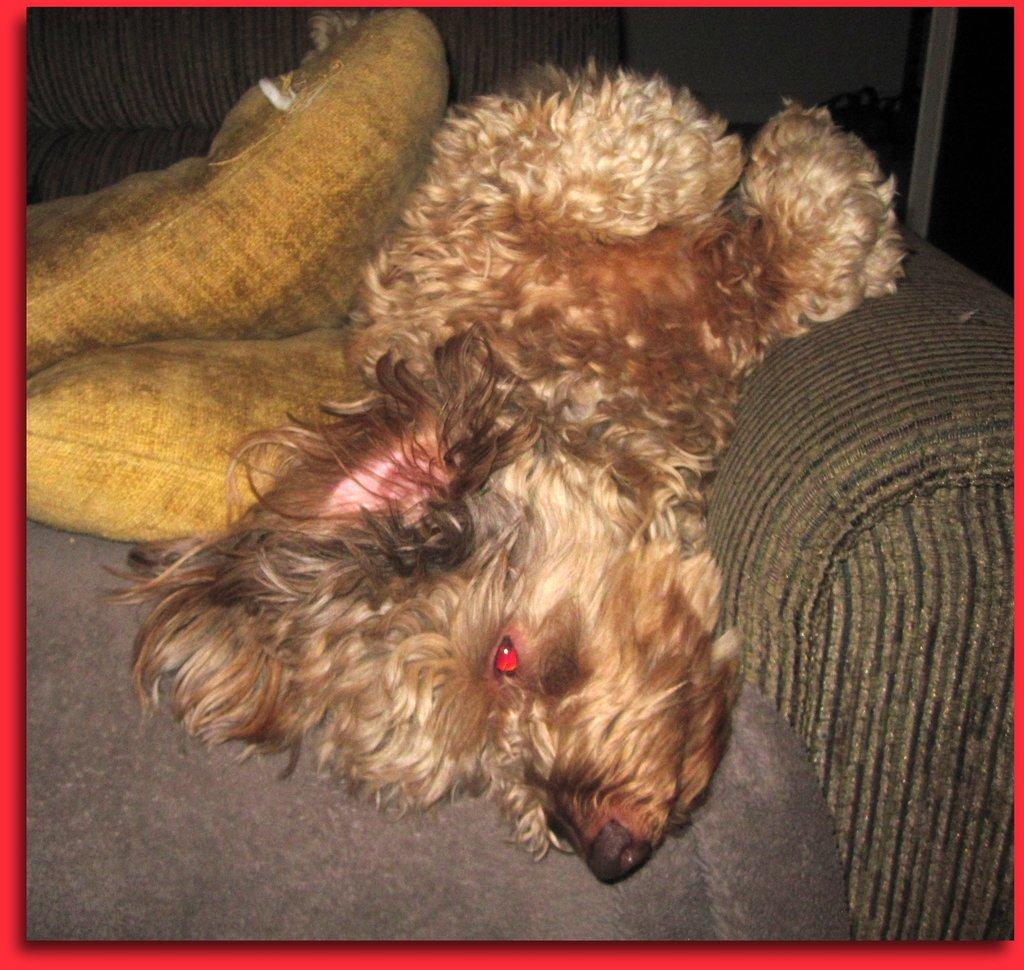What is featured on the poster in the image? The poster contains an image of a couch. What is placed on the couch in the image? There are pillows on the couch. Can you describe any living creatures in the image? Yes, there appears to be a puppy in the image. What scientific form is the puppy taking in the image? The image does not depict the puppy in a scientific form; it is simply a puppy in the image. What type of test is being conducted with the poster and pillows in the image? There is no test being conducted in the image; it is simply a depiction of a poster, a couch with pillows, and a puppy. 